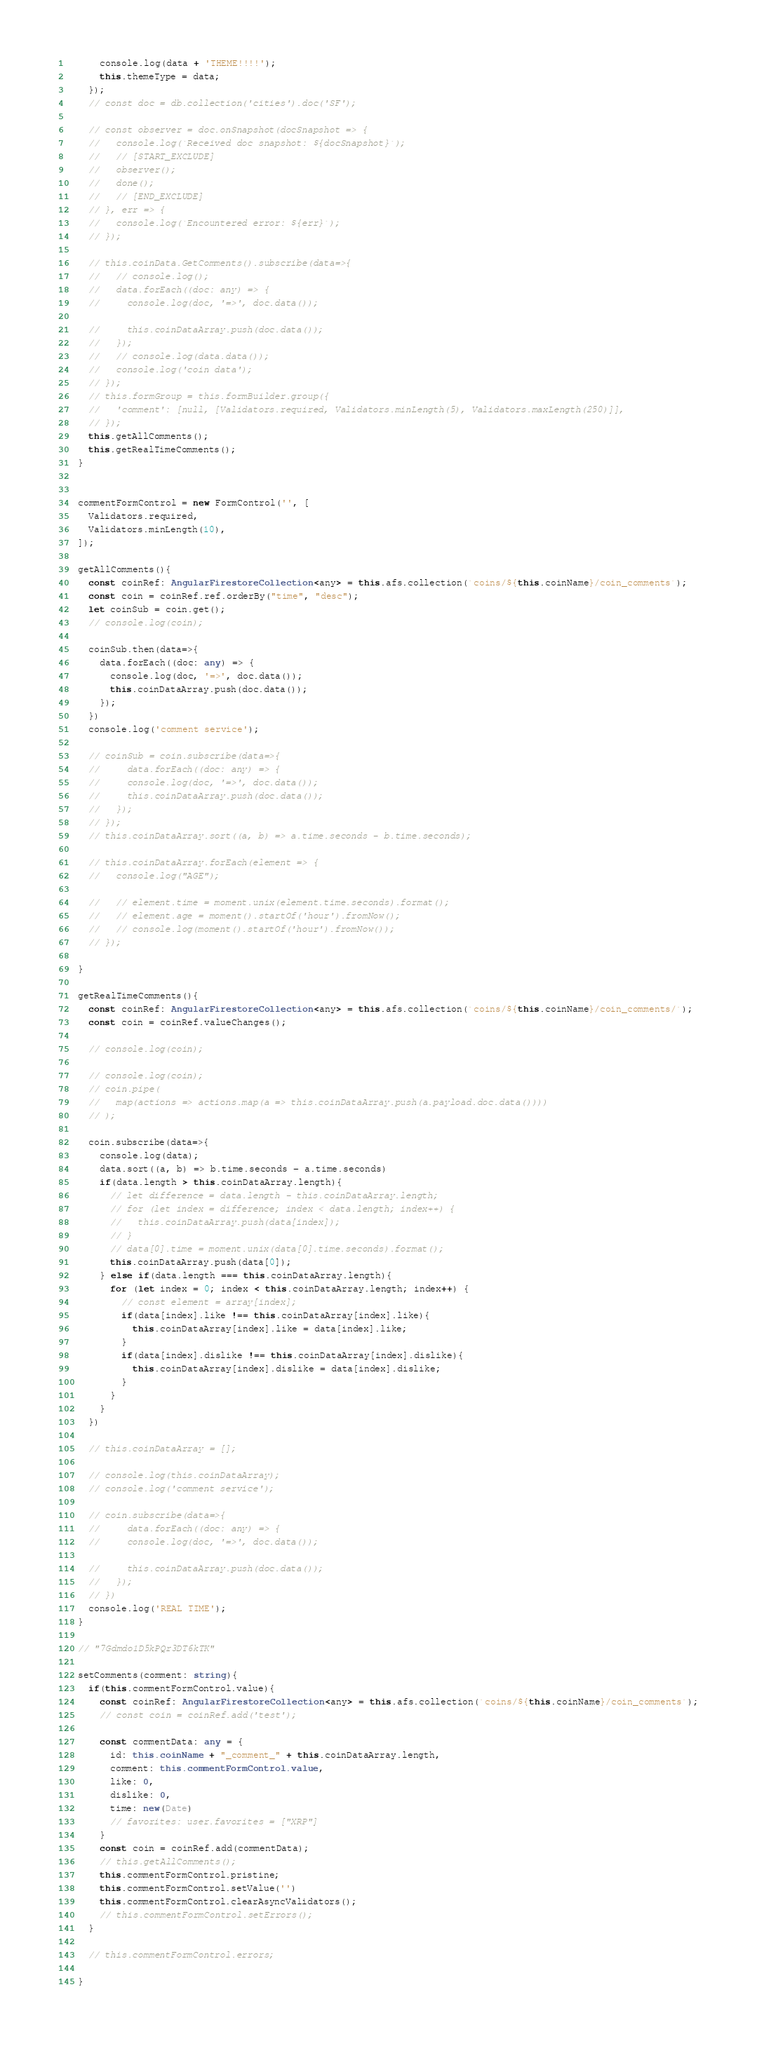<code> <loc_0><loc_0><loc_500><loc_500><_TypeScript_>      console.log(data + 'THEME!!!!');
      this.themeType = data;
    });
    // const doc = db.collection('cities').doc('SF');

    // const observer = doc.onSnapshot(docSnapshot => {
    //   console.log(`Received doc snapshot: ${docSnapshot}`);
    //   // [START_EXCLUDE]
    //   observer();
    //   done();
    //   // [END_EXCLUDE]
    // }, err => {
    //   console.log(`Encountered error: ${err}`);
    // });

    // this.coinData.GetComments().subscribe(data=>{
    //   // console.log();
    //   data.forEach((doc: any) => {
    //     console.log(doc, '=>', doc.data());

    //     this.coinDataArray.push(doc.data());
    //   });
    //   // console.log(data.data());
    //   console.log('coin data');
    // });
    // this.formGroup = this.formBuilder.group({
    //   'comment': [null, [Validators.required, Validators.minLength(5), Validators.maxLength(250)]],
    // });
    this.getAllComments();
    this.getRealTimeComments();
  }


  commentFormControl = new FormControl('', [
    Validators.required,
    Validators.minLength(10),
  ]);

  getAllComments(){
    const coinRef: AngularFirestoreCollection<any> = this.afs.collection(`coins/${this.coinName}/coin_comments`);
    const coin = coinRef.ref.orderBy("time", "desc");
    let coinSub = coin.get();
    // console.log(coin);

    coinSub.then(data=>{
      data.forEach((doc: any) => {
        console.log(doc, '=>', doc.data());
        this.coinDataArray.push(doc.data());
      });
    })
    console.log('comment service');

    // coinSub = coin.subscribe(data=>{
    //     data.forEach((doc: any) => {
    //     console.log(doc, '=>', doc.data());
    //     this.coinDataArray.push(doc.data());
    //   });
    // });
    // this.coinDataArray.sort((a, b) => a.time.seconds - b.time.seconds);

    // this.coinDataArray.forEach(element => {
    //   console.log("AGE");

    //   // element.time = moment.unix(element.time.seconds).format();
    //   // element.age = moment().startOf('hour').fromNow();
    //   // console.log(moment().startOf('hour').fromNow());
    // });

  }

  getRealTimeComments(){
    const coinRef: AngularFirestoreCollection<any> = this.afs.collection(`coins/${this.coinName}/coin_comments/`);
    const coin = coinRef.valueChanges();

    // console.log(coin);

    // console.log(coin);
    // coin.pipe(
    //   map(actions => actions.map(a => this.coinDataArray.push(a.payload.doc.data())))
    // );

    coin.subscribe(data=>{
      console.log(data);
      data.sort((a, b) => b.time.seconds - a.time.seconds)
      if(data.length > this.coinDataArray.length){
        // let difference = data.length - this.coinDataArray.length;
        // for (let index = difference; index < data.length; index++) {
        //   this.coinDataArray.push(data[index]);
        // }
        // data[0].time = moment.unix(data[0].time.seconds).format();
        this.coinDataArray.push(data[0]);
      } else if(data.length === this.coinDataArray.length){
        for (let index = 0; index < this.coinDataArray.length; index++) {
          // const element = array[index];
          if(data[index].like !== this.coinDataArray[index].like){
            this.coinDataArray[index].like = data[index].like;
          }
          if(data[index].dislike !== this.coinDataArray[index].dislike){
            this.coinDataArray[index].dislike = data[index].dislike;
          }
        }
      }
    })

    // this.coinDataArray = [];

    // console.log(this.coinDataArray);
    // console.log('comment service');

    // coin.subscribe(data=>{
    //     data.forEach((doc: any) => {
    //     console.log(doc, '=>', doc.data());

    //     this.coinDataArray.push(doc.data());
    //   });
    // })
    console.log('REAL TIME');
  }

  // "7Gdmdo1D5kPQr3DT6kTK"

  setComments(comment: string){
    if(this.commentFormControl.value){
      const coinRef: AngularFirestoreCollection<any> = this.afs.collection(`coins/${this.coinName}/coin_comments`);
      // const coin = coinRef.add('test');

      const commentData: any = {
        id: this.coinName + "_comment_" + this.coinDataArray.length,
        comment: this.commentFormControl.value,
        like: 0,
        dislike: 0,
        time: new(Date)
        // favorites: user.favorites = ["XRP"]
      }
      const coin = coinRef.add(commentData);
      // this.getAllComments();
      this.commentFormControl.pristine;
      this.commentFormControl.setValue('')
      this.commentFormControl.clearAsyncValidators();
      // this.commentFormControl.setErrors();
    }

    // this.commentFormControl.errors;

  }
</code> 